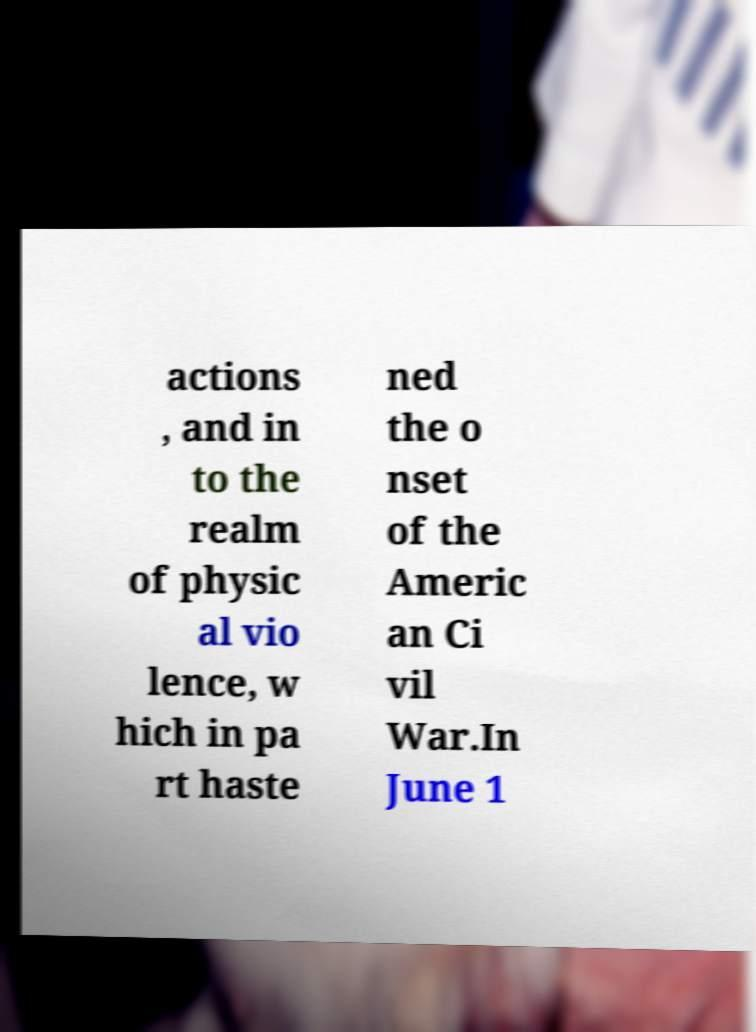Can you accurately transcribe the text from the provided image for me? actions , and in to the realm of physic al vio lence, w hich in pa rt haste ned the o nset of the Americ an Ci vil War.In June 1 